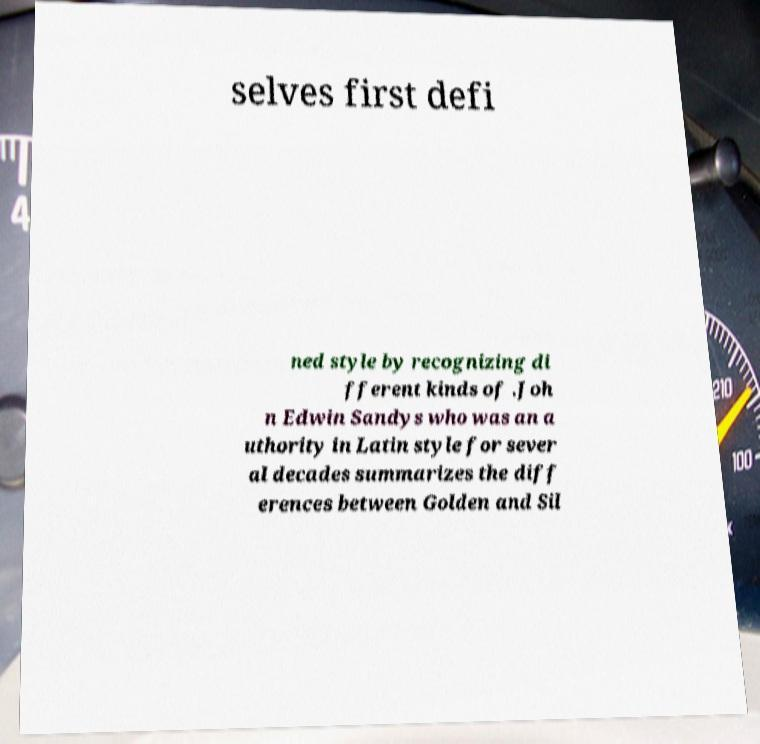I need the written content from this picture converted into text. Can you do that? selves first defi ned style by recognizing di fferent kinds of .Joh n Edwin Sandys who was an a uthority in Latin style for sever al decades summarizes the diff erences between Golden and Sil 